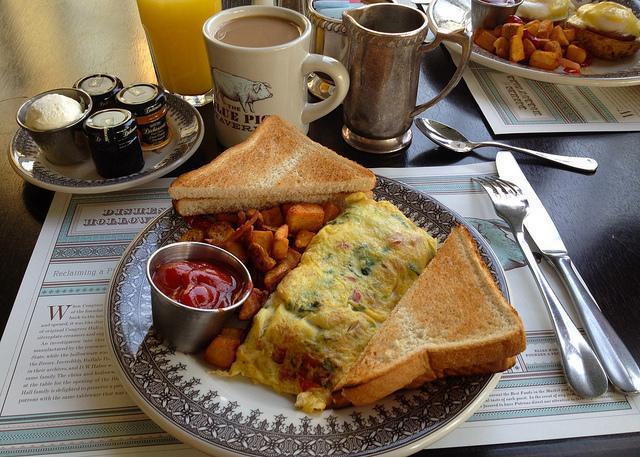How many plates are there?
Give a very brief answer. 3. How many dining tables can you see?
Give a very brief answer. 2. How many sandwiches can you see?
Give a very brief answer. 3. How many cups are there?
Give a very brief answer. 3. 